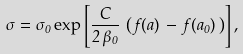<formula> <loc_0><loc_0><loc_500><loc_500>\sigma = \sigma _ { 0 } \exp \left [ \frac { C } { 2 \, \beta _ { 0 } } \, \left ( \, f ( a ) \, - \, f ( a _ { 0 } ) \, \right ) \right ] ,</formula> 